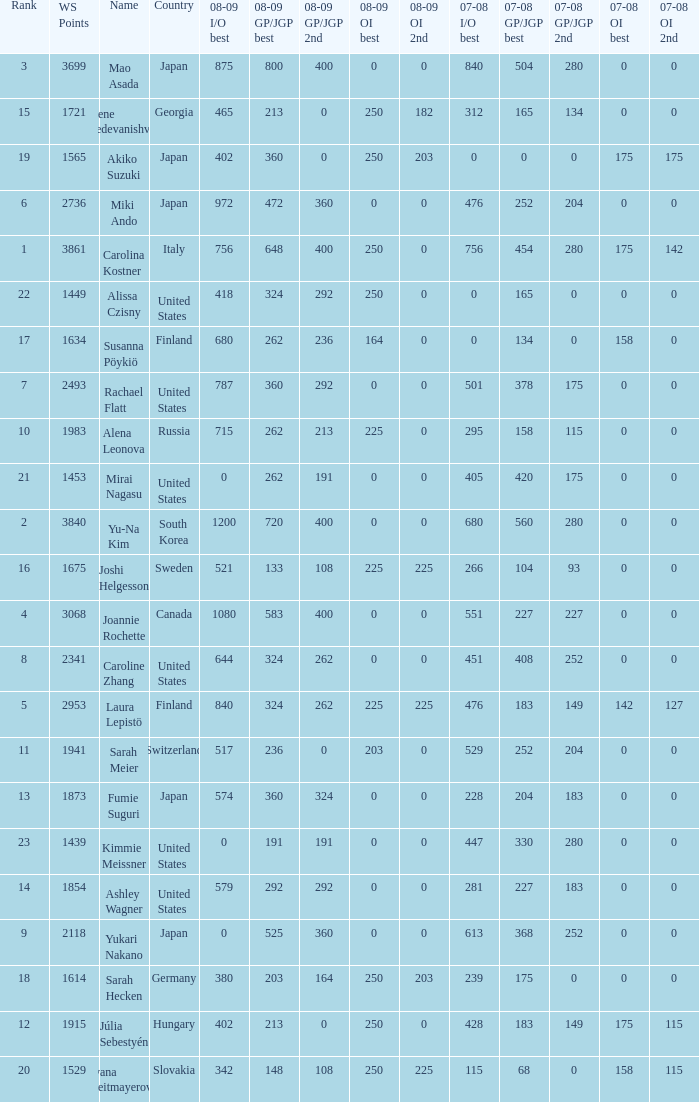08-09 gp/jgp 2nd is 213 and ws points will be what highest? 1983.0. 